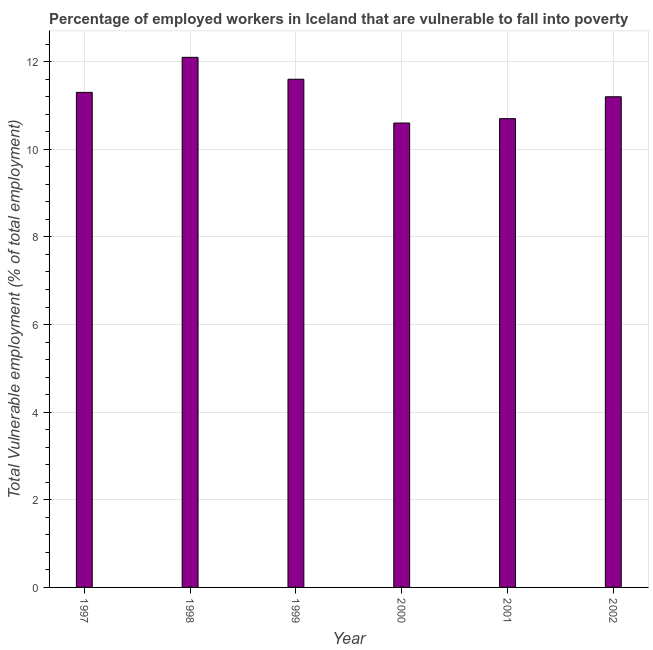What is the title of the graph?
Keep it short and to the point. Percentage of employed workers in Iceland that are vulnerable to fall into poverty. What is the label or title of the X-axis?
Offer a terse response. Year. What is the label or title of the Y-axis?
Your response must be concise. Total Vulnerable employment (% of total employment). What is the total vulnerable employment in 1997?
Provide a succinct answer. 11.3. Across all years, what is the maximum total vulnerable employment?
Your answer should be very brief. 12.1. Across all years, what is the minimum total vulnerable employment?
Your answer should be very brief. 10.6. In which year was the total vulnerable employment minimum?
Your response must be concise. 2000. What is the sum of the total vulnerable employment?
Offer a terse response. 67.5. What is the average total vulnerable employment per year?
Provide a succinct answer. 11.25. What is the median total vulnerable employment?
Your answer should be very brief. 11.25. Do a majority of the years between 1999 and 1998 (inclusive) have total vulnerable employment greater than 8.4 %?
Keep it short and to the point. No. What is the ratio of the total vulnerable employment in 2001 to that in 2002?
Provide a succinct answer. 0.95. What is the difference between the highest and the second highest total vulnerable employment?
Your answer should be compact. 0.5. What is the difference between the highest and the lowest total vulnerable employment?
Make the answer very short. 1.5. How many bars are there?
Offer a very short reply. 6. How many years are there in the graph?
Your answer should be very brief. 6. What is the difference between two consecutive major ticks on the Y-axis?
Your answer should be very brief. 2. Are the values on the major ticks of Y-axis written in scientific E-notation?
Your answer should be very brief. No. What is the Total Vulnerable employment (% of total employment) in 1997?
Your response must be concise. 11.3. What is the Total Vulnerable employment (% of total employment) of 1998?
Ensure brevity in your answer.  12.1. What is the Total Vulnerable employment (% of total employment) of 1999?
Make the answer very short. 11.6. What is the Total Vulnerable employment (% of total employment) in 2000?
Provide a succinct answer. 10.6. What is the Total Vulnerable employment (% of total employment) in 2001?
Your answer should be very brief. 10.7. What is the Total Vulnerable employment (% of total employment) in 2002?
Give a very brief answer. 11.2. What is the difference between the Total Vulnerable employment (% of total employment) in 1997 and 1999?
Your response must be concise. -0.3. What is the difference between the Total Vulnerable employment (% of total employment) in 1997 and 2002?
Give a very brief answer. 0.1. What is the difference between the Total Vulnerable employment (% of total employment) in 1998 and 2000?
Offer a terse response. 1.5. What is the difference between the Total Vulnerable employment (% of total employment) in 1998 and 2001?
Your response must be concise. 1.4. What is the difference between the Total Vulnerable employment (% of total employment) in 1998 and 2002?
Ensure brevity in your answer.  0.9. What is the difference between the Total Vulnerable employment (% of total employment) in 1999 and 2001?
Provide a succinct answer. 0.9. What is the difference between the Total Vulnerable employment (% of total employment) in 2001 and 2002?
Make the answer very short. -0.5. What is the ratio of the Total Vulnerable employment (% of total employment) in 1997 to that in 1998?
Make the answer very short. 0.93. What is the ratio of the Total Vulnerable employment (% of total employment) in 1997 to that in 2000?
Your answer should be very brief. 1.07. What is the ratio of the Total Vulnerable employment (% of total employment) in 1997 to that in 2001?
Your answer should be very brief. 1.06. What is the ratio of the Total Vulnerable employment (% of total employment) in 1997 to that in 2002?
Your response must be concise. 1.01. What is the ratio of the Total Vulnerable employment (% of total employment) in 1998 to that in 1999?
Your response must be concise. 1.04. What is the ratio of the Total Vulnerable employment (% of total employment) in 1998 to that in 2000?
Offer a very short reply. 1.14. What is the ratio of the Total Vulnerable employment (% of total employment) in 1998 to that in 2001?
Keep it short and to the point. 1.13. What is the ratio of the Total Vulnerable employment (% of total employment) in 1998 to that in 2002?
Provide a succinct answer. 1.08. What is the ratio of the Total Vulnerable employment (% of total employment) in 1999 to that in 2000?
Offer a terse response. 1.09. What is the ratio of the Total Vulnerable employment (% of total employment) in 1999 to that in 2001?
Make the answer very short. 1.08. What is the ratio of the Total Vulnerable employment (% of total employment) in 1999 to that in 2002?
Ensure brevity in your answer.  1.04. What is the ratio of the Total Vulnerable employment (% of total employment) in 2000 to that in 2001?
Your answer should be very brief. 0.99. What is the ratio of the Total Vulnerable employment (% of total employment) in 2000 to that in 2002?
Give a very brief answer. 0.95. What is the ratio of the Total Vulnerable employment (% of total employment) in 2001 to that in 2002?
Offer a very short reply. 0.95. 